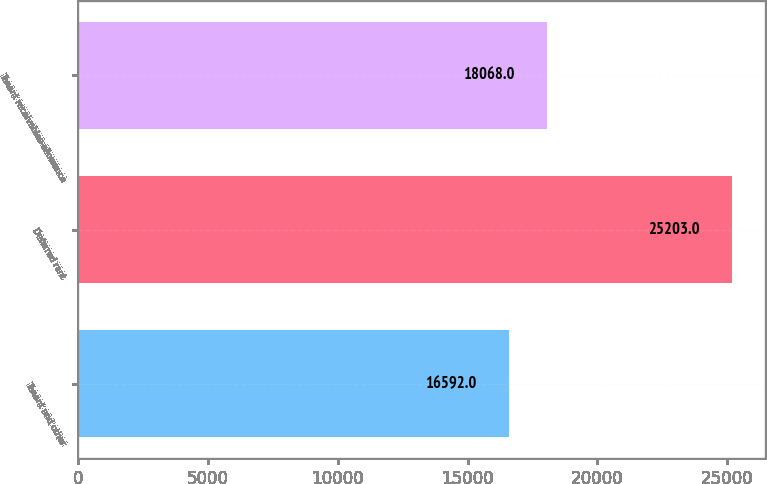Convert chart to OTSL. <chart><loc_0><loc_0><loc_500><loc_500><bar_chart><fcel>Tenant and other<fcel>Deferred rent<fcel>Tenant receivables-allowance<nl><fcel>16592<fcel>25203<fcel>18068<nl></chart> 